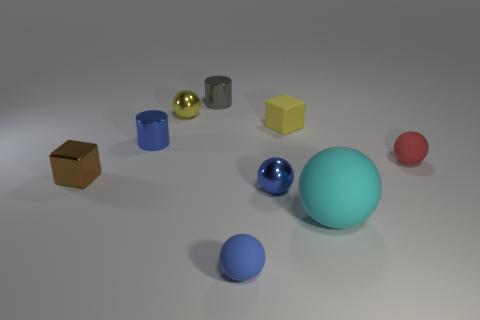There is a red rubber object that is behind the small blue sphere that is on the left side of the tiny blue metal ball; what is its shape?
Offer a very short reply. Sphere. Are there the same number of yellow things that are in front of the blue rubber object and green rubber things?
Your answer should be compact. Yes. What is the material of the cylinder that is in front of the small shiny sphere left of the tiny metal cylinder behind the yellow cube?
Your answer should be compact. Metal. Is there a sphere that has the same size as the blue shiny cylinder?
Give a very brief answer. Yes. There is a tiny blue matte object; what shape is it?
Provide a succinct answer. Sphere. What number of balls are either blue objects or cyan rubber things?
Keep it short and to the point. 3. Are there an equal number of gray shiny objects that are to the left of the small brown block and small blue metallic cylinders that are in front of the blue rubber ball?
Provide a succinct answer. Yes. How many rubber things are behind the small rubber object in front of the brown metallic block to the left of the small red ball?
Your answer should be compact. 3. Does the tiny rubber cube have the same color as the metallic ball behind the metal block?
Make the answer very short. Yes. Is the number of gray metallic things that are behind the yellow matte cube greater than the number of big metallic cylinders?
Ensure brevity in your answer.  Yes. 